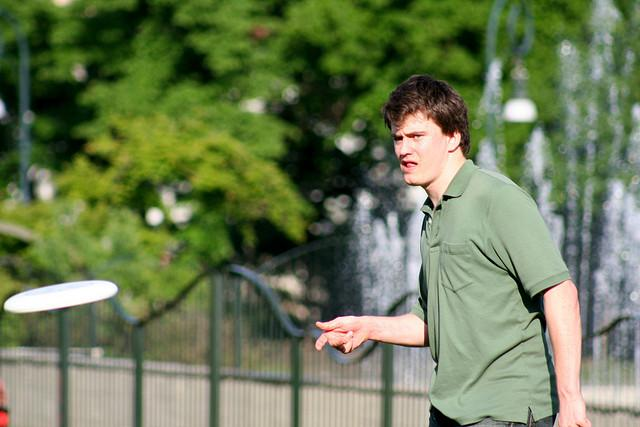The color of the shirt matches the color of what? trees 